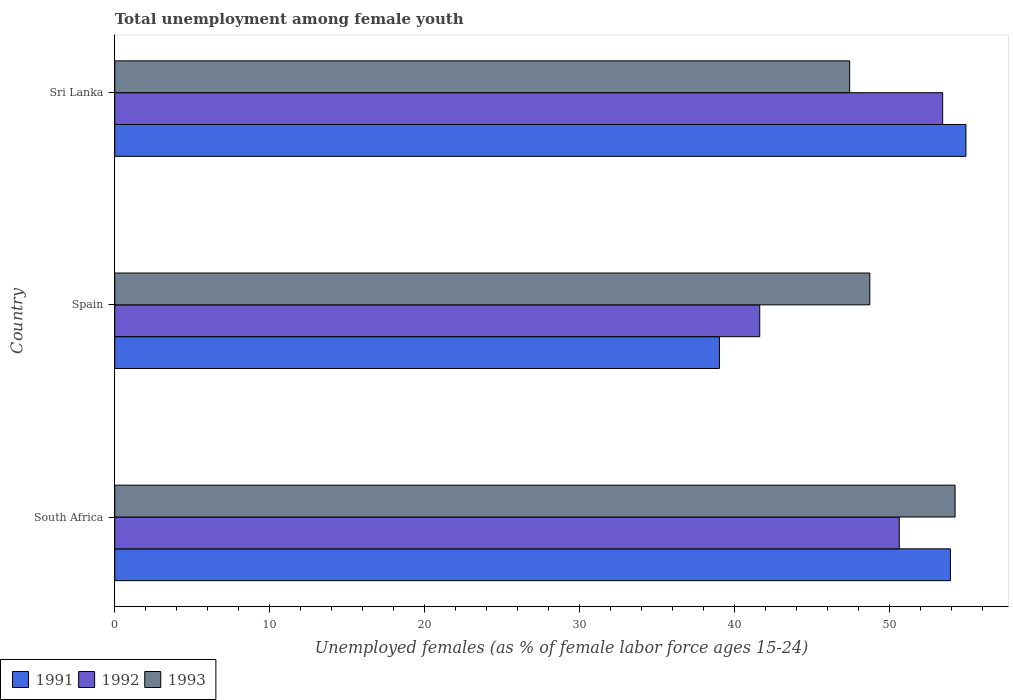How many groups of bars are there?
Your answer should be compact. 3. Are the number of bars per tick equal to the number of legend labels?
Make the answer very short. Yes. How many bars are there on the 1st tick from the bottom?
Offer a terse response. 3. What is the label of the 3rd group of bars from the top?
Provide a short and direct response. South Africa. What is the percentage of unemployed females in in 1992 in South Africa?
Ensure brevity in your answer.  50.6. Across all countries, what is the maximum percentage of unemployed females in in 1991?
Your response must be concise. 54.9. Across all countries, what is the minimum percentage of unemployed females in in 1993?
Ensure brevity in your answer.  47.4. In which country was the percentage of unemployed females in in 1993 maximum?
Offer a terse response. South Africa. In which country was the percentage of unemployed females in in 1993 minimum?
Provide a short and direct response. Sri Lanka. What is the total percentage of unemployed females in in 1993 in the graph?
Give a very brief answer. 150.3. What is the difference between the percentage of unemployed females in in 1991 in South Africa and that in Spain?
Offer a very short reply. 14.9. What is the difference between the percentage of unemployed females in in 1991 in Spain and the percentage of unemployed females in in 1992 in South Africa?
Offer a very short reply. -11.6. What is the average percentage of unemployed females in in 1993 per country?
Keep it short and to the point. 50.1. In how many countries, is the percentage of unemployed females in in 1992 greater than 12 %?
Your answer should be very brief. 3. What is the ratio of the percentage of unemployed females in in 1993 in South Africa to that in Sri Lanka?
Offer a terse response. 1.14. Is the percentage of unemployed females in in 1993 in South Africa less than that in Sri Lanka?
Provide a succinct answer. No. What is the difference between the highest and the second highest percentage of unemployed females in in 1992?
Keep it short and to the point. 2.8. What is the difference between the highest and the lowest percentage of unemployed females in in 1991?
Your answer should be compact. 15.9. In how many countries, is the percentage of unemployed females in in 1992 greater than the average percentage of unemployed females in in 1992 taken over all countries?
Offer a very short reply. 2. What does the 3rd bar from the bottom in Sri Lanka represents?
Offer a terse response. 1993. How many bars are there?
Provide a succinct answer. 9. Are all the bars in the graph horizontal?
Offer a terse response. Yes. What is the difference between two consecutive major ticks on the X-axis?
Your answer should be very brief. 10. Are the values on the major ticks of X-axis written in scientific E-notation?
Provide a succinct answer. No. Does the graph contain grids?
Offer a terse response. No. How many legend labels are there?
Ensure brevity in your answer.  3. What is the title of the graph?
Make the answer very short. Total unemployment among female youth. What is the label or title of the X-axis?
Provide a succinct answer. Unemployed females (as % of female labor force ages 15-24). What is the Unemployed females (as % of female labor force ages 15-24) in 1991 in South Africa?
Your answer should be very brief. 53.9. What is the Unemployed females (as % of female labor force ages 15-24) of 1992 in South Africa?
Ensure brevity in your answer.  50.6. What is the Unemployed females (as % of female labor force ages 15-24) in 1993 in South Africa?
Provide a succinct answer. 54.2. What is the Unemployed females (as % of female labor force ages 15-24) in 1992 in Spain?
Offer a very short reply. 41.6. What is the Unemployed females (as % of female labor force ages 15-24) of 1993 in Spain?
Your answer should be compact. 48.7. What is the Unemployed females (as % of female labor force ages 15-24) in 1991 in Sri Lanka?
Your answer should be compact. 54.9. What is the Unemployed females (as % of female labor force ages 15-24) of 1992 in Sri Lanka?
Offer a very short reply. 53.4. What is the Unemployed females (as % of female labor force ages 15-24) in 1993 in Sri Lanka?
Your response must be concise. 47.4. Across all countries, what is the maximum Unemployed females (as % of female labor force ages 15-24) of 1991?
Make the answer very short. 54.9. Across all countries, what is the maximum Unemployed females (as % of female labor force ages 15-24) of 1992?
Your answer should be very brief. 53.4. Across all countries, what is the maximum Unemployed females (as % of female labor force ages 15-24) of 1993?
Provide a succinct answer. 54.2. Across all countries, what is the minimum Unemployed females (as % of female labor force ages 15-24) in 1992?
Your answer should be very brief. 41.6. Across all countries, what is the minimum Unemployed females (as % of female labor force ages 15-24) of 1993?
Your answer should be compact. 47.4. What is the total Unemployed females (as % of female labor force ages 15-24) in 1991 in the graph?
Ensure brevity in your answer.  147.8. What is the total Unemployed females (as % of female labor force ages 15-24) in 1992 in the graph?
Provide a short and direct response. 145.6. What is the total Unemployed females (as % of female labor force ages 15-24) of 1993 in the graph?
Your answer should be very brief. 150.3. What is the difference between the Unemployed females (as % of female labor force ages 15-24) of 1992 in South Africa and that in Spain?
Keep it short and to the point. 9. What is the difference between the Unemployed females (as % of female labor force ages 15-24) in 1992 in South Africa and that in Sri Lanka?
Give a very brief answer. -2.8. What is the difference between the Unemployed females (as % of female labor force ages 15-24) in 1993 in South Africa and that in Sri Lanka?
Provide a short and direct response. 6.8. What is the difference between the Unemployed females (as % of female labor force ages 15-24) of 1991 in Spain and that in Sri Lanka?
Provide a succinct answer. -15.9. What is the difference between the Unemployed females (as % of female labor force ages 15-24) in 1992 in Spain and that in Sri Lanka?
Give a very brief answer. -11.8. What is the difference between the Unemployed females (as % of female labor force ages 15-24) in 1993 in Spain and that in Sri Lanka?
Give a very brief answer. 1.3. What is the difference between the Unemployed females (as % of female labor force ages 15-24) of 1991 in South Africa and the Unemployed females (as % of female labor force ages 15-24) of 1992 in Spain?
Keep it short and to the point. 12.3. What is the difference between the Unemployed females (as % of female labor force ages 15-24) of 1992 in South Africa and the Unemployed females (as % of female labor force ages 15-24) of 1993 in Sri Lanka?
Your answer should be very brief. 3.2. What is the difference between the Unemployed females (as % of female labor force ages 15-24) of 1991 in Spain and the Unemployed females (as % of female labor force ages 15-24) of 1992 in Sri Lanka?
Your answer should be compact. -14.4. What is the average Unemployed females (as % of female labor force ages 15-24) of 1991 per country?
Ensure brevity in your answer.  49.27. What is the average Unemployed females (as % of female labor force ages 15-24) of 1992 per country?
Provide a succinct answer. 48.53. What is the average Unemployed females (as % of female labor force ages 15-24) in 1993 per country?
Your answer should be very brief. 50.1. What is the difference between the Unemployed females (as % of female labor force ages 15-24) in 1991 and Unemployed females (as % of female labor force ages 15-24) in 1993 in South Africa?
Offer a terse response. -0.3. What is the difference between the Unemployed females (as % of female labor force ages 15-24) in 1991 and Unemployed females (as % of female labor force ages 15-24) in 1992 in Spain?
Your answer should be very brief. -2.6. What is the difference between the Unemployed females (as % of female labor force ages 15-24) of 1992 and Unemployed females (as % of female labor force ages 15-24) of 1993 in Spain?
Your answer should be very brief. -7.1. What is the ratio of the Unemployed females (as % of female labor force ages 15-24) in 1991 in South Africa to that in Spain?
Your response must be concise. 1.38. What is the ratio of the Unemployed females (as % of female labor force ages 15-24) of 1992 in South Africa to that in Spain?
Keep it short and to the point. 1.22. What is the ratio of the Unemployed females (as % of female labor force ages 15-24) of 1993 in South Africa to that in Spain?
Make the answer very short. 1.11. What is the ratio of the Unemployed females (as % of female labor force ages 15-24) of 1991 in South Africa to that in Sri Lanka?
Ensure brevity in your answer.  0.98. What is the ratio of the Unemployed females (as % of female labor force ages 15-24) of 1992 in South Africa to that in Sri Lanka?
Offer a terse response. 0.95. What is the ratio of the Unemployed females (as % of female labor force ages 15-24) in 1993 in South Africa to that in Sri Lanka?
Ensure brevity in your answer.  1.14. What is the ratio of the Unemployed females (as % of female labor force ages 15-24) in 1991 in Spain to that in Sri Lanka?
Your answer should be very brief. 0.71. What is the ratio of the Unemployed females (as % of female labor force ages 15-24) of 1992 in Spain to that in Sri Lanka?
Ensure brevity in your answer.  0.78. What is the ratio of the Unemployed females (as % of female labor force ages 15-24) in 1993 in Spain to that in Sri Lanka?
Your answer should be compact. 1.03. What is the difference between the highest and the second highest Unemployed females (as % of female labor force ages 15-24) of 1991?
Ensure brevity in your answer.  1. What is the difference between the highest and the second highest Unemployed females (as % of female labor force ages 15-24) of 1992?
Keep it short and to the point. 2.8. What is the difference between the highest and the lowest Unemployed females (as % of female labor force ages 15-24) in 1991?
Your answer should be very brief. 15.9. What is the difference between the highest and the lowest Unemployed females (as % of female labor force ages 15-24) in 1992?
Offer a very short reply. 11.8. What is the difference between the highest and the lowest Unemployed females (as % of female labor force ages 15-24) in 1993?
Ensure brevity in your answer.  6.8. 